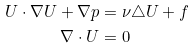<formula> <loc_0><loc_0><loc_500><loc_500>U \cdot \nabla U + \nabla p & = \nu \triangle U + f \\ \nabla \cdot U & = 0</formula> 